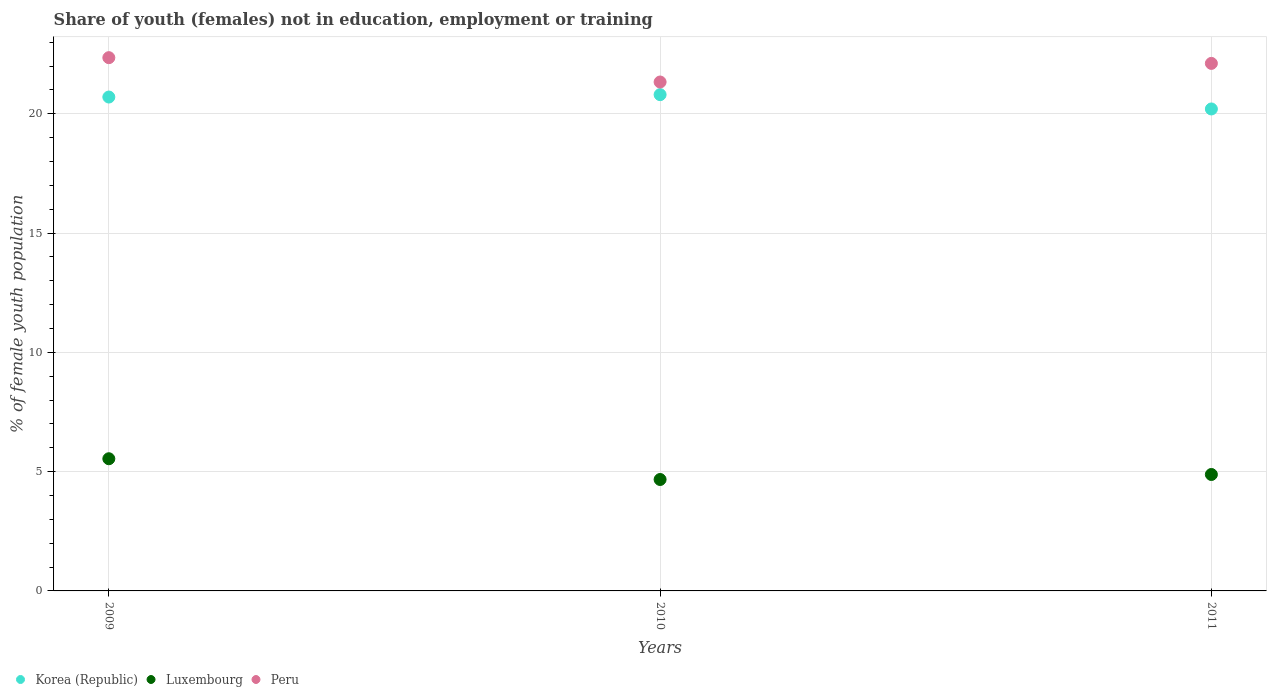Is the number of dotlines equal to the number of legend labels?
Ensure brevity in your answer.  Yes. What is the percentage of unemployed female population in in Korea (Republic) in 2011?
Give a very brief answer. 20.2. Across all years, what is the maximum percentage of unemployed female population in in Peru?
Your answer should be very brief. 22.35. Across all years, what is the minimum percentage of unemployed female population in in Peru?
Offer a very short reply. 21.33. In which year was the percentage of unemployed female population in in Peru maximum?
Make the answer very short. 2009. In which year was the percentage of unemployed female population in in Korea (Republic) minimum?
Offer a terse response. 2011. What is the total percentage of unemployed female population in in Korea (Republic) in the graph?
Make the answer very short. 61.7. What is the difference between the percentage of unemployed female population in in Luxembourg in 2009 and that in 2011?
Give a very brief answer. 0.66. What is the difference between the percentage of unemployed female population in in Korea (Republic) in 2011 and the percentage of unemployed female population in in Luxembourg in 2010?
Provide a short and direct response. 15.53. What is the average percentage of unemployed female population in in Korea (Republic) per year?
Offer a terse response. 20.57. In the year 2009, what is the difference between the percentage of unemployed female population in in Korea (Republic) and percentage of unemployed female population in in Peru?
Keep it short and to the point. -1.65. What is the ratio of the percentage of unemployed female population in in Peru in 2009 to that in 2011?
Provide a succinct answer. 1.01. Is the difference between the percentage of unemployed female population in in Korea (Republic) in 2009 and 2011 greater than the difference between the percentage of unemployed female population in in Peru in 2009 and 2011?
Offer a terse response. Yes. What is the difference between the highest and the second highest percentage of unemployed female population in in Peru?
Ensure brevity in your answer.  0.24. What is the difference between the highest and the lowest percentage of unemployed female population in in Korea (Republic)?
Ensure brevity in your answer.  0.6. In how many years, is the percentage of unemployed female population in in Peru greater than the average percentage of unemployed female population in in Peru taken over all years?
Give a very brief answer. 2. Is it the case that in every year, the sum of the percentage of unemployed female population in in Luxembourg and percentage of unemployed female population in in Korea (Republic)  is greater than the percentage of unemployed female population in in Peru?
Offer a terse response. Yes. Does the percentage of unemployed female population in in Peru monotonically increase over the years?
Provide a succinct answer. No. Is the percentage of unemployed female population in in Luxembourg strictly less than the percentage of unemployed female population in in Korea (Republic) over the years?
Your answer should be compact. Yes. How many years are there in the graph?
Ensure brevity in your answer.  3. How many legend labels are there?
Give a very brief answer. 3. What is the title of the graph?
Offer a terse response. Share of youth (females) not in education, employment or training. Does "United Arab Emirates" appear as one of the legend labels in the graph?
Provide a short and direct response. No. What is the label or title of the Y-axis?
Your answer should be very brief. % of female youth population. What is the % of female youth population of Korea (Republic) in 2009?
Keep it short and to the point. 20.7. What is the % of female youth population in Luxembourg in 2009?
Your response must be concise. 5.54. What is the % of female youth population of Peru in 2009?
Keep it short and to the point. 22.35. What is the % of female youth population of Korea (Republic) in 2010?
Keep it short and to the point. 20.8. What is the % of female youth population of Luxembourg in 2010?
Keep it short and to the point. 4.67. What is the % of female youth population of Peru in 2010?
Offer a very short reply. 21.33. What is the % of female youth population in Korea (Republic) in 2011?
Your answer should be compact. 20.2. What is the % of female youth population in Luxembourg in 2011?
Keep it short and to the point. 4.88. What is the % of female youth population of Peru in 2011?
Offer a very short reply. 22.11. Across all years, what is the maximum % of female youth population in Korea (Republic)?
Ensure brevity in your answer.  20.8. Across all years, what is the maximum % of female youth population of Luxembourg?
Ensure brevity in your answer.  5.54. Across all years, what is the maximum % of female youth population in Peru?
Provide a succinct answer. 22.35. Across all years, what is the minimum % of female youth population of Korea (Republic)?
Your response must be concise. 20.2. Across all years, what is the minimum % of female youth population of Luxembourg?
Give a very brief answer. 4.67. Across all years, what is the minimum % of female youth population of Peru?
Provide a succinct answer. 21.33. What is the total % of female youth population of Korea (Republic) in the graph?
Your answer should be very brief. 61.7. What is the total % of female youth population of Luxembourg in the graph?
Provide a succinct answer. 15.09. What is the total % of female youth population in Peru in the graph?
Provide a succinct answer. 65.79. What is the difference between the % of female youth population in Korea (Republic) in 2009 and that in 2010?
Offer a very short reply. -0.1. What is the difference between the % of female youth population of Luxembourg in 2009 and that in 2010?
Provide a short and direct response. 0.87. What is the difference between the % of female youth population of Korea (Republic) in 2009 and that in 2011?
Provide a succinct answer. 0.5. What is the difference between the % of female youth population of Luxembourg in 2009 and that in 2011?
Your answer should be very brief. 0.66. What is the difference between the % of female youth population of Peru in 2009 and that in 2011?
Offer a terse response. 0.24. What is the difference between the % of female youth population of Korea (Republic) in 2010 and that in 2011?
Ensure brevity in your answer.  0.6. What is the difference between the % of female youth population of Luxembourg in 2010 and that in 2011?
Offer a very short reply. -0.21. What is the difference between the % of female youth population in Peru in 2010 and that in 2011?
Make the answer very short. -0.78. What is the difference between the % of female youth population in Korea (Republic) in 2009 and the % of female youth population in Luxembourg in 2010?
Offer a very short reply. 16.03. What is the difference between the % of female youth population in Korea (Republic) in 2009 and the % of female youth population in Peru in 2010?
Ensure brevity in your answer.  -0.63. What is the difference between the % of female youth population in Luxembourg in 2009 and the % of female youth population in Peru in 2010?
Provide a succinct answer. -15.79. What is the difference between the % of female youth population in Korea (Republic) in 2009 and the % of female youth population in Luxembourg in 2011?
Offer a very short reply. 15.82. What is the difference between the % of female youth population in Korea (Republic) in 2009 and the % of female youth population in Peru in 2011?
Make the answer very short. -1.41. What is the difference between the % of female youth population in Luxembourg in 2009 and the % of female youth population in Peru in 2011?
Your answer should be very brief. -16.57. What is the difference between the % of female youth population in Korea (Republic) in 2010 and the % of female youth population in Luxembourg in 2011?
Ensure brevity in your answer.  15.92. What is the difference between the % of female youth population in Korea (Republic) in 2010 and the % of female youth population in Peru in 2011?
Provide a succinct answer. -1.31. What is the difference between the % of female youth population of Luxembourg in 2010 and the % of female youth population of Peru in 2011?
Provide a short and direct response. -17.44. What is the average % of female youth population in Korea (Republic) per year?
Provide a short and direct response. 20.57. What is the average % of female youth population of Luxembourg per year?
Offer a terse response. 5.03. What is the average % of female youth population in Peru per year?
Your answer should be compact. 21.93. In the year 2009, what is the difference between the % of female youth population of Korea (Republic) and % of female youth population of Luxembourg?
Provide a succinct answer. 15.16. In the year 2009, what is the difference between the % of female youth population of Korea (Republic) and % of female youth population of Peru?
Your response must be concise. -1.65. In the year 2009, what is the difference between the % of female youth population of Luxembourg and % of female youth population of Peru?
Make the answer very short. -16.81. In the year 2010, what is the difference between the % of female youth population in Korea (Republic) and % of female youth population in Luxembourg?
Provide a succinct answer. 16.13. In the year 2010, what is the difference between the % of female youth population in Korea (Republic) and % of female youth population in Peru?
Provide a succinct answer. -0.53. In the year 2010, what is the difference between the % of female youth population in Luxembourg and % of female youth population in Peru?
Your response must be concise. -16.66. In the year 2011, what is the difference between the % of female youth population of Korea (Republic) and % of female youth population of Luxembourg?
Give a very brief answer. 15.32. In the year 2011, what is the difference between the % of female youth population of Korea (Republic) and % of female youth population of Peru?
Your answer should be compact. -1.91. In the year 2011, what is the difference between the % of female youth population of Luxembourg and % of female youth population of Peru?
Your answer should be very brief. -17.23. What is the ratio of the % of female youth population of Luxembourg in 2009 to that in 2010?
Your response must be concise. 1.19. What is the ratio of the % of female youth population of Peru in 2009 to that in 2010?
Provide a succinct answer. 1.05. What is the ratio of the % of female youth population in Korea (Republic) in 2009 to that in 2011?
Make the answer very short. 1.02. What is the ratio of the % of female youth population in Luxembourg in 2009 to that in 2011?
Ensure brevity in your answer.  1.14. What is the ratio of the % of female youth population in Peru in 2009 to that in 2011?
Provide a short and direct response. 1.01. What is the ratio of the % of female youth population of Korea (Republic) in 2010 to that in 2011?
Ensure brevity in your answer.  1.03. What is the ratio of the % of female youth population of Luxembourg in 2010 to that in 2011?
Your response must be concise. 0.96. What is the ratio of the % of female youth population in Peru in 2010 to that in 2011?
Your answer should be compact. 0.96. What is the difference between the highest and the second highest % of female youth population of Luxembourg?
Give a very brief answer. 0.66. What is the difference between the highest and the second highest % of female youth population in Peru?
Keep it short and to the point. 0.24. What is the difference between the highest and the lowest % of female youth population of Luxembourg?
Your answer should be compact. 0.87. What is the difference between the highest and the lowest % of female youth population in Peru?
Provide a succinct answer. 1.02. 